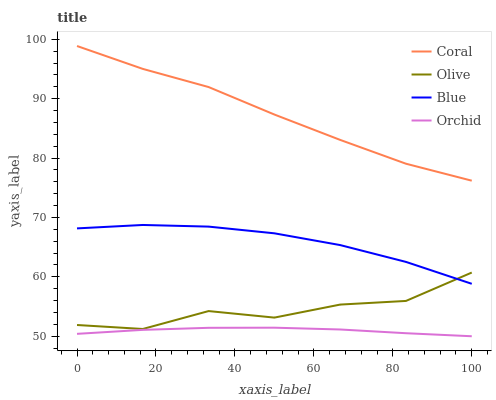Does Orchid have the minimum area under the curve?
Answer yes or no. Yes. Does Coral have the maximum area under the curve?
Answer yes or no. Yes. Does Blue have the minimum area under the curve?
Answer yes or no. No. Does Blue have the maximum area under the curve?
Answer yes or no. No. Is Orchid the smoothest?
Answer yes or no. Yes. Is Olive the roughest?
Answer yes or no. Yes. Is Blue the smoothest?
Answer yes or no. No. Is Blue the roughest?
Answer yes or no. No. Does Blue have the lowest value?
Answer yes or no. No. Does Blue have the highest value?
Answer yes or no. No. Is Orchid less than Blue?
Answer yes or no. Yes. Is Olive greater than Orchid?
Answer yes or no. Yes. Does Orchid intersect Blue?
Answer yes or no. No. 